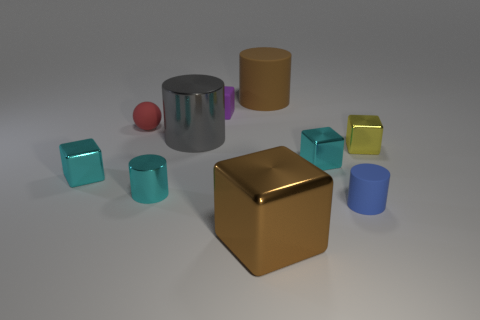Subtract all gray balls. How many cyan cubes are left? 2 Subtract all large matte cylinders. How many cylinders are left? 3 Subtract 3 cubes. How many cubes are left? 2 Subtract all blue cylinders. How many cylinders are left? 3 Subtract all green blocks. Subtract all brown balls. How many blocks are left? 5 Subtract all cylinders. How many objects are left? 6 Subtract 0 gray blocks. How many objects are left? 10 Subtract all cyan metallic cylinders. Subtract all small red things. How many objects are left? 8 Add 6 tiny cyan blocks. How many tiny cyan blocks are left? 8 Add 4 big gray matte spheres. How many big gray matte spheres exist? 4 